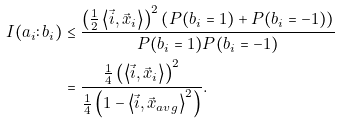<formula> <loc_0><loc_0><loc_500><loc_500>I ( a _ { i } \colon b _ { i } ) & \leq \frac { \left ( \frac { 1 } { 2 } \left \langle \vec { i } , \vec { x } _ { i } \right \rangle \right ) ^ { 2 } \left ( P ( b _ { i } = 1 ) + P ( b _ { i } = - 1 ) \right ) } { P ( b _ { i } = 1 ) P ( b _ { i } = - 1 ) } \\ & = \frac { \frac { 1 } { 4 } \left ( \left \langle \vec { i } , \vec { x } _ { i } \right \rangle \right ) ^ { 2 } } { \frac { 1 } { 4 } \left ( 1 - \left \langle \vec { i } , \vec { x } _ { a v g } \right \rangle ^ { 2 } \right ) } .</formula> 